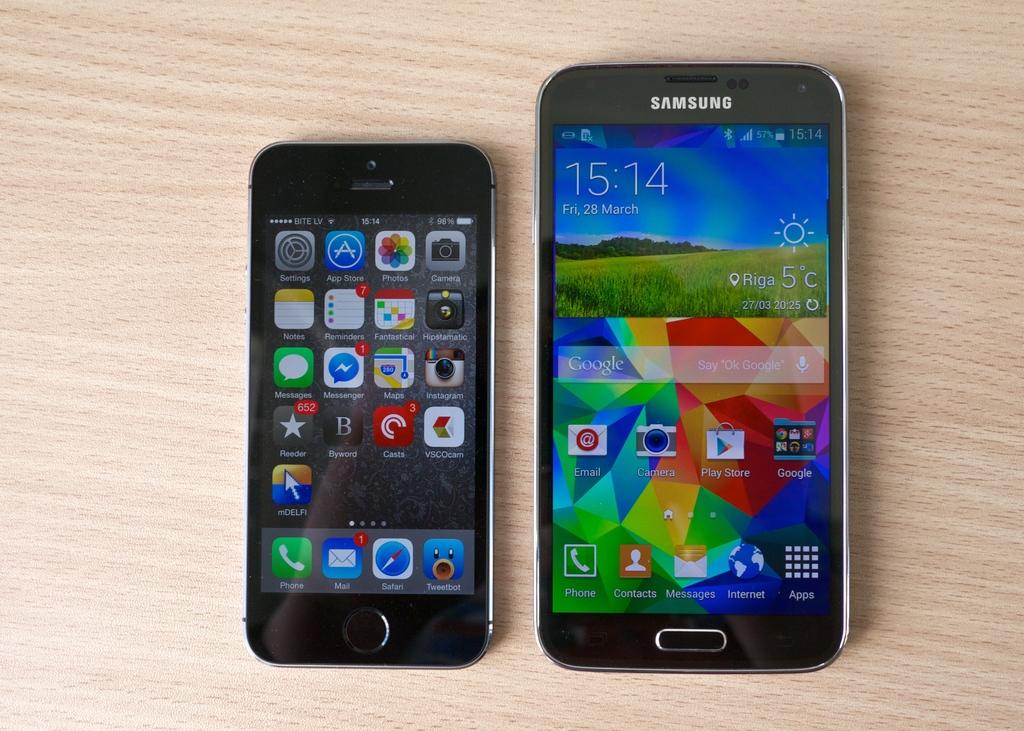What time is shown on the phone on the right?
Your answer should be very brief. 15:14. What brand is the phone on the right?
Offer a very short reply. Samsung. 